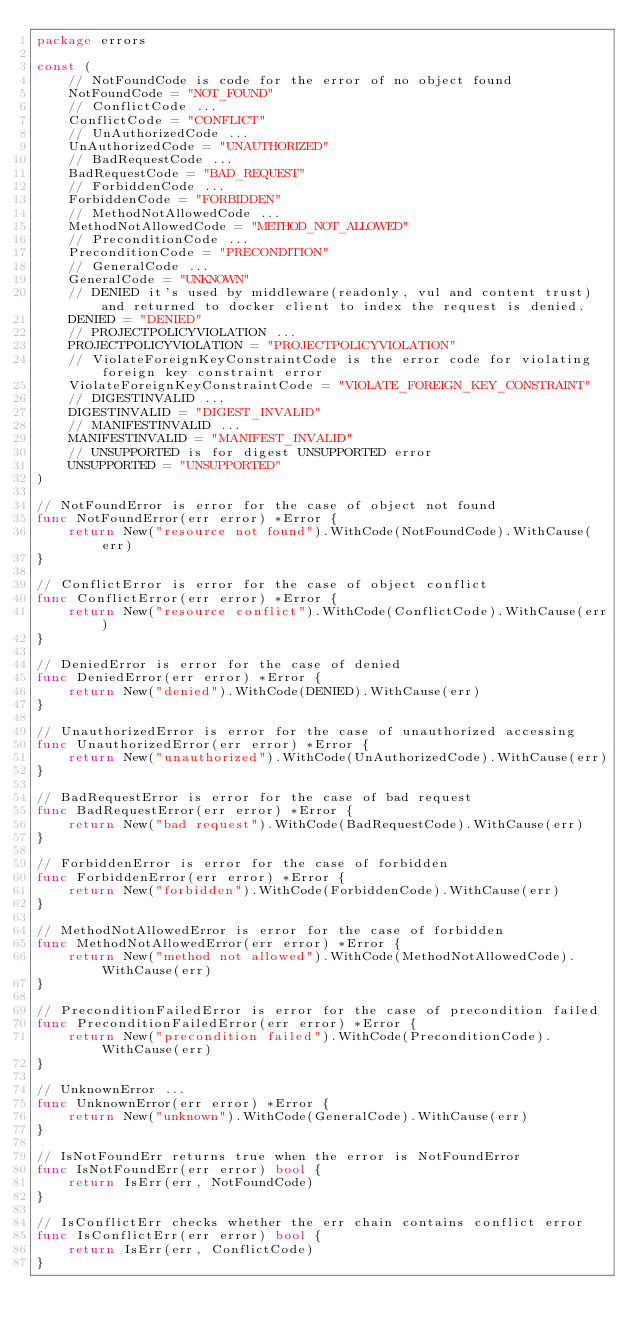<code> <loc_0><loc_0><loc_500><loc_500><_Go_>package errors

const (
	// NotFoundCode is code for the error of no object found
	NotFoundCode = "NOT_FOUND"
	// ConflictCode ...
	ConflictCode = "CONFLICT"
	// UnAuthorizedCode ...
	UnAuthorizedCode = "UNAUTHORIZED"
	// BadRequestCode ...
	BadRequestCode = "BAD_REQUEST"
	// ForbiddenCode ...
	ForbiddenCode = "FORBIDDEN"
	// MethodNotAllowedCode ...
	MethodNotAllowedCode = "METHOD_NOT_ALLOWED"
	// PreconditionCode ...
	PreconditionCode = "PRECONDITION"
	// GeneralCode ...
	GeneralCode = "UNKNOWN"
	// DENIED it's used by middleware(readonly, vul and content trust) and returned to docker client to index the request is denied.
	DENIED = "DENIED"
	// PROJECTPOLICYVIOLATION ...
	PROJECTPOLICYVIOLATION = "PROJECTPOLICYVIOLATION"
	// ViolateForeignKeyConstraintCode is the error code for violating foreign key constraint error
	ViolateForeignKeyConstraintCode = "VIOLATE_FOREIGN_KEY_CONSTRAINT"
	// DIGESTINVALID ...
	DIGESTINVALID = "DIGEST_INVALID"
	// MANIFESTINVALID ...
	MANIFESTINVALID = "MANIFEST_INVALID"
	// UNSUPPORTED is for digest UNSUPPORTED error
	UNSUPPORTED = "UNSUPPORTED"
)

// NotFoundError is error for the case of object not found
func NotFoundError(err error) *Error {
	return New("resource not found").WithCode(NotFoundCode).WithCause(err)
}

// ConflictError is error for the case of object conflict
func ConflictError(err error) *Error {
	return New("resource conflict").WithCode(ConflictCode).WithCause(err)
}

// DeniedError is error for the case of denied
func DeniedError(err error) *Error {
	return New("denied").WithCode(DENIED).WithCause(err)
}

// UnauthorizedError is error for the case of unauthorized accessing
func UnauthorizedError(err error) *Error {
	return New("unauthorized").WithCode(UnAuthorizedCode).WithCause(err)
}

// BadRequestError is error for the case of bad request
func BadRequestError(err error) *Error {
	return New("bad request").WithCode(BadRequestCode).WithCause(err)
}

// ForbiddenError is error for the case of forbidden
func ForbiddenError(err error) *Error {
	return New("forbidden").WithCode(ForbiddenCode).WithCause(err)
}

// MethodNotAllowedError is error for the case of forbidden
func MethodNotAllowedError(err error) *Error {
	return New("method not allowed").WithCode(MethodNotAllowedCode).WithCause(err)
}

// PreconditionFailedError is error for the case of precondition failed
func PreconditionFailedError(err error) *Error {
	return New("precondition failed").WithCode(PreconditionCode).WithCause(err)
}

// UnknownError ...
func UnknownError(err error) *Error {
	return New("unknown").WithCode(GeneralCode).WithCause(err)
}

// IsNotFoundErr returns true when the error is NotFoundError
func IsNotFoundErr(err error) bool {
	return IsErr(err, NotFoundCode)
}

// IsConflictErr checks whether the err chain contains conflict error
func IsConflictErr(err error) bool {
	return IsErr(err, ConflictCode)
}
</code> 